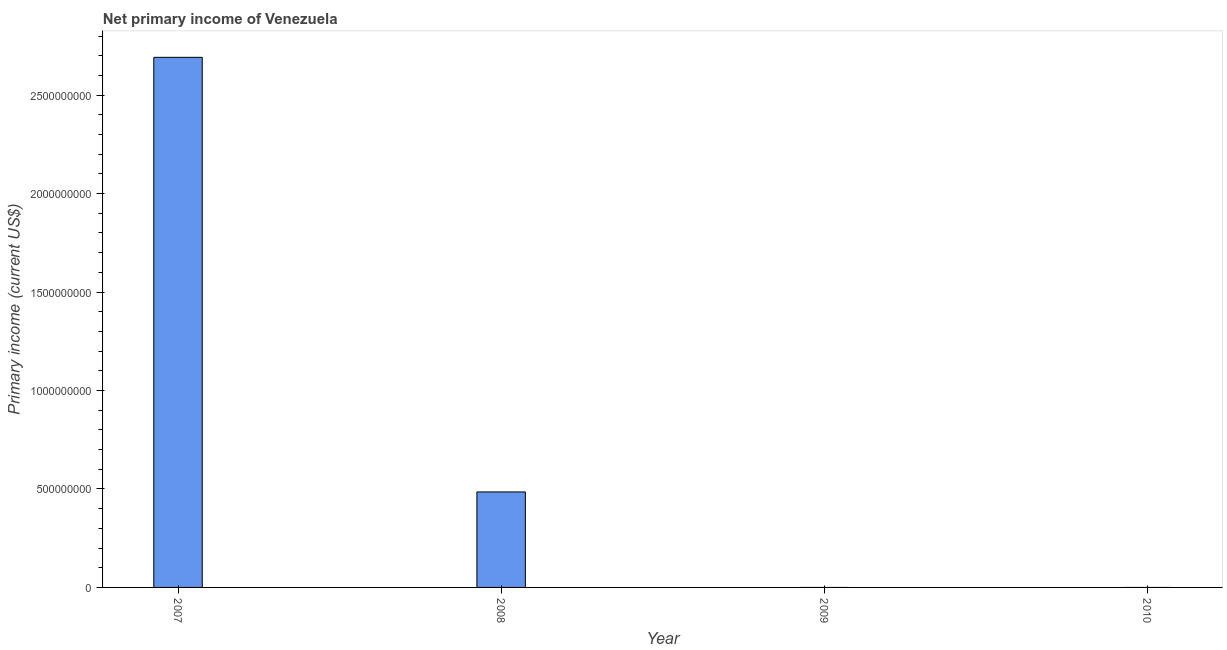Does the graph contain any zero values?
Keep it short and to the point. Yes. What is the title of the graph?
Ensure brevity in your answer.  Net primary income of Venezuela. What is the label or title of the X-axis?
Keep it short and to the point. Year. What is the label or title of the Y-axis?
Provide a succinct answer. Primary income (current US$). What is the amount of primary income in 2009?
Your answer should be very brief. 0. Across all years, what is the maximum amount of primary income?
Your answer should be compact. 2.69e+09. What is the sum of the amount of primary income?
Keep it short and to the point. 3.18e+09. What is the difference between the amount of primary income in 2007 and 2008?
Keep it short and to the point. 2.21e+09. What is the average amount of primary income per year?
Your answer should be very brief. 7.94e+08. What is the median amount of primary income?
Provide a short and direct response. 2.42e+08. In how many years, is the amount of primary income greater than 2200000000 US$?
Provide a short and direct response. 1. What is the difference between the highest and the lowest amount of primary income?
Your response must be concise. 2.69e+09. In how many years, is the amount of primary income greater than the average amount of primary income taken over all years?
Offer a terse response. 1. How many bars are there?
Your answer should be very brief. 2. Are all the bars in the graph horizontal?
Make the answer very short. No. Are the values on the major ticks of Y-axis written in scientific E-notation?
Give a very brief answer. No. What is the Primary income (current US$) in 2007?
Provide a short and direct response. 2.69e+09. What is the Primary income (current US$) of 2008?
Offer a very short reply. 4.85e+08. What is the Primary income (current US$) of 2009?
Keep it short and to the point. 0. What is the difference between the Primary income (current US$) in 2007 and 2008?
Give a very brief answer. 2.21e+09. What is the ratio of the Primary income (current US$) in 2007 to that in 2008?
Offer a very short reply. 5.55. 